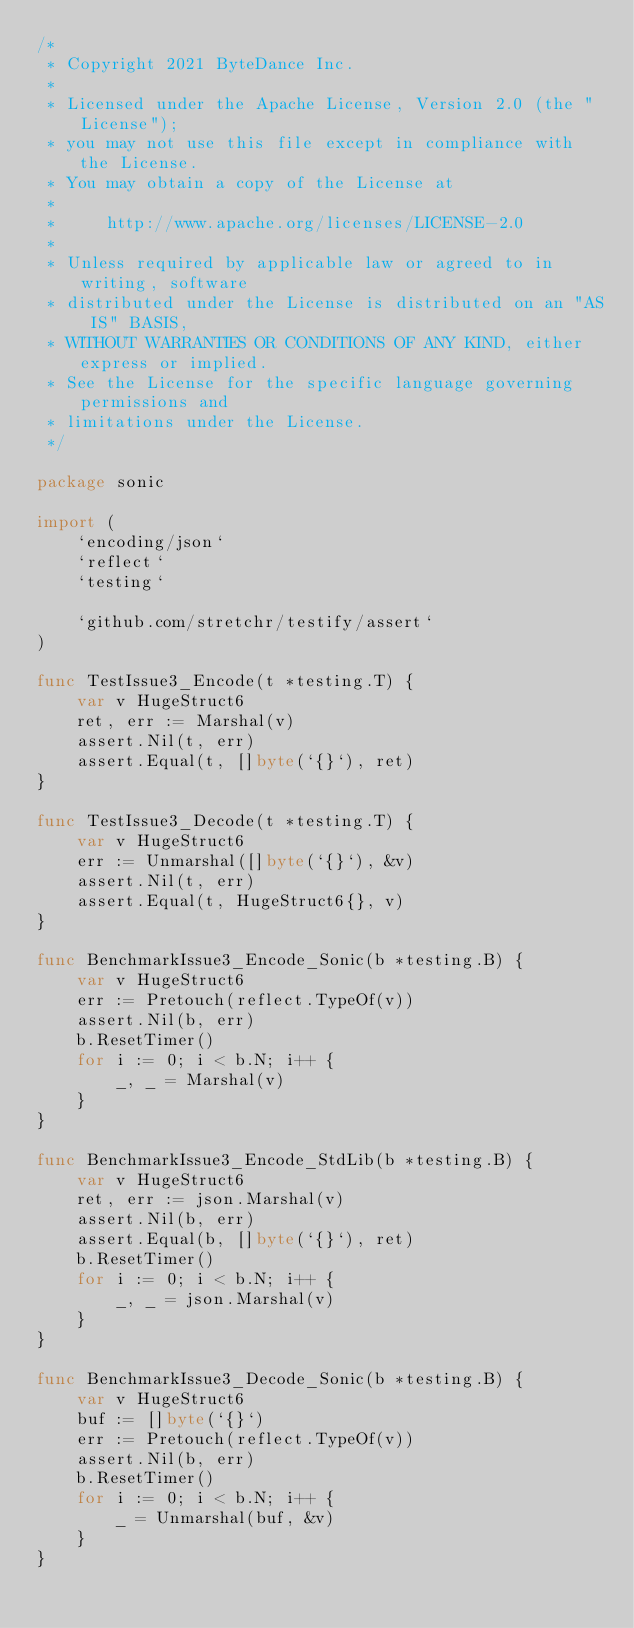<code> <loc_0><loc_0><loc_500><loc_500><_Go_>/*
 * Copyright 2021 ByteDance Inc.
 *
 * Licensed under the Apache License, Version 2.0 (the "License");
 * you may not use this file except in compliance with the License.
 * You may obtain a copy of the License at
 *
 *     http://www.apache.org/licenses/LICENSE-2.0
 *
 * Unless required by applicable law or agreed to in writing, software
 * distributed under the License is distributed on an "AS IS" BASIS,
 * WITHOUT WARRANTIES OR CONDITIONS OF ANY KIND, either express or implied.
 * See the License for the specific language governing permissions and
 * limitations under the License.
 */

package sonic

import (
    `encoding/json`
    `reflect`
    `testing`

    `github.com/stretchr/testify/assert`
)

func TestIssue3_Encode(t *testing.T) {
    var v HugeStruct6
    ret, err := Marshal(v)
    assert.Nil(t, err)
    assert.Equal(t, []byte(`{}`), ret)
}

func TestIssue3_Decode(t *testing.T) {
    var v HugeStruct6
    err := Unmarshal([]byte(`{}`), &v)
    assert.Nil(t, err)
    assert.Equal(t, HugeStruct6{}, v)
}

func BenchmarkIssue3_Encode_Sonic(b *testing.B) {
    var v HugeStruct6
    err := Pretouch(reflect.TypeOf(v))
    assert.Nil(b, err)
    b.ResetTimer()
    for i := 0; i < b.N; i++ {
        _, _ = Marshal(v)
    }
}

func BenchmarkIssue3_Encode_StdLib(b *testing.B) {
    var v HugeStruct6
    ret, err := json.Marshal(v)
    assert.Nil(b, err)
    assert.Equal(b, []byte(`{}`), ret)
    b.ResetTimer()
    for i := 0; i < b.N; i++ {
        _, _ = json.Marshal(v)
    }
}

func BenchmarkIssue3_Decode_Sonic(b *testing.B) {
    var v HugeStruct6
    buf := []byte(`{}`)
    err := Pretouch(reflect.TypeOf(v))
    assert.Nil(b, err)
    b.ResetTimer()
    for i := 0; i < b.N; i++ {
        _ = Unmarshal(buf, &v)
    }
}
</code> 